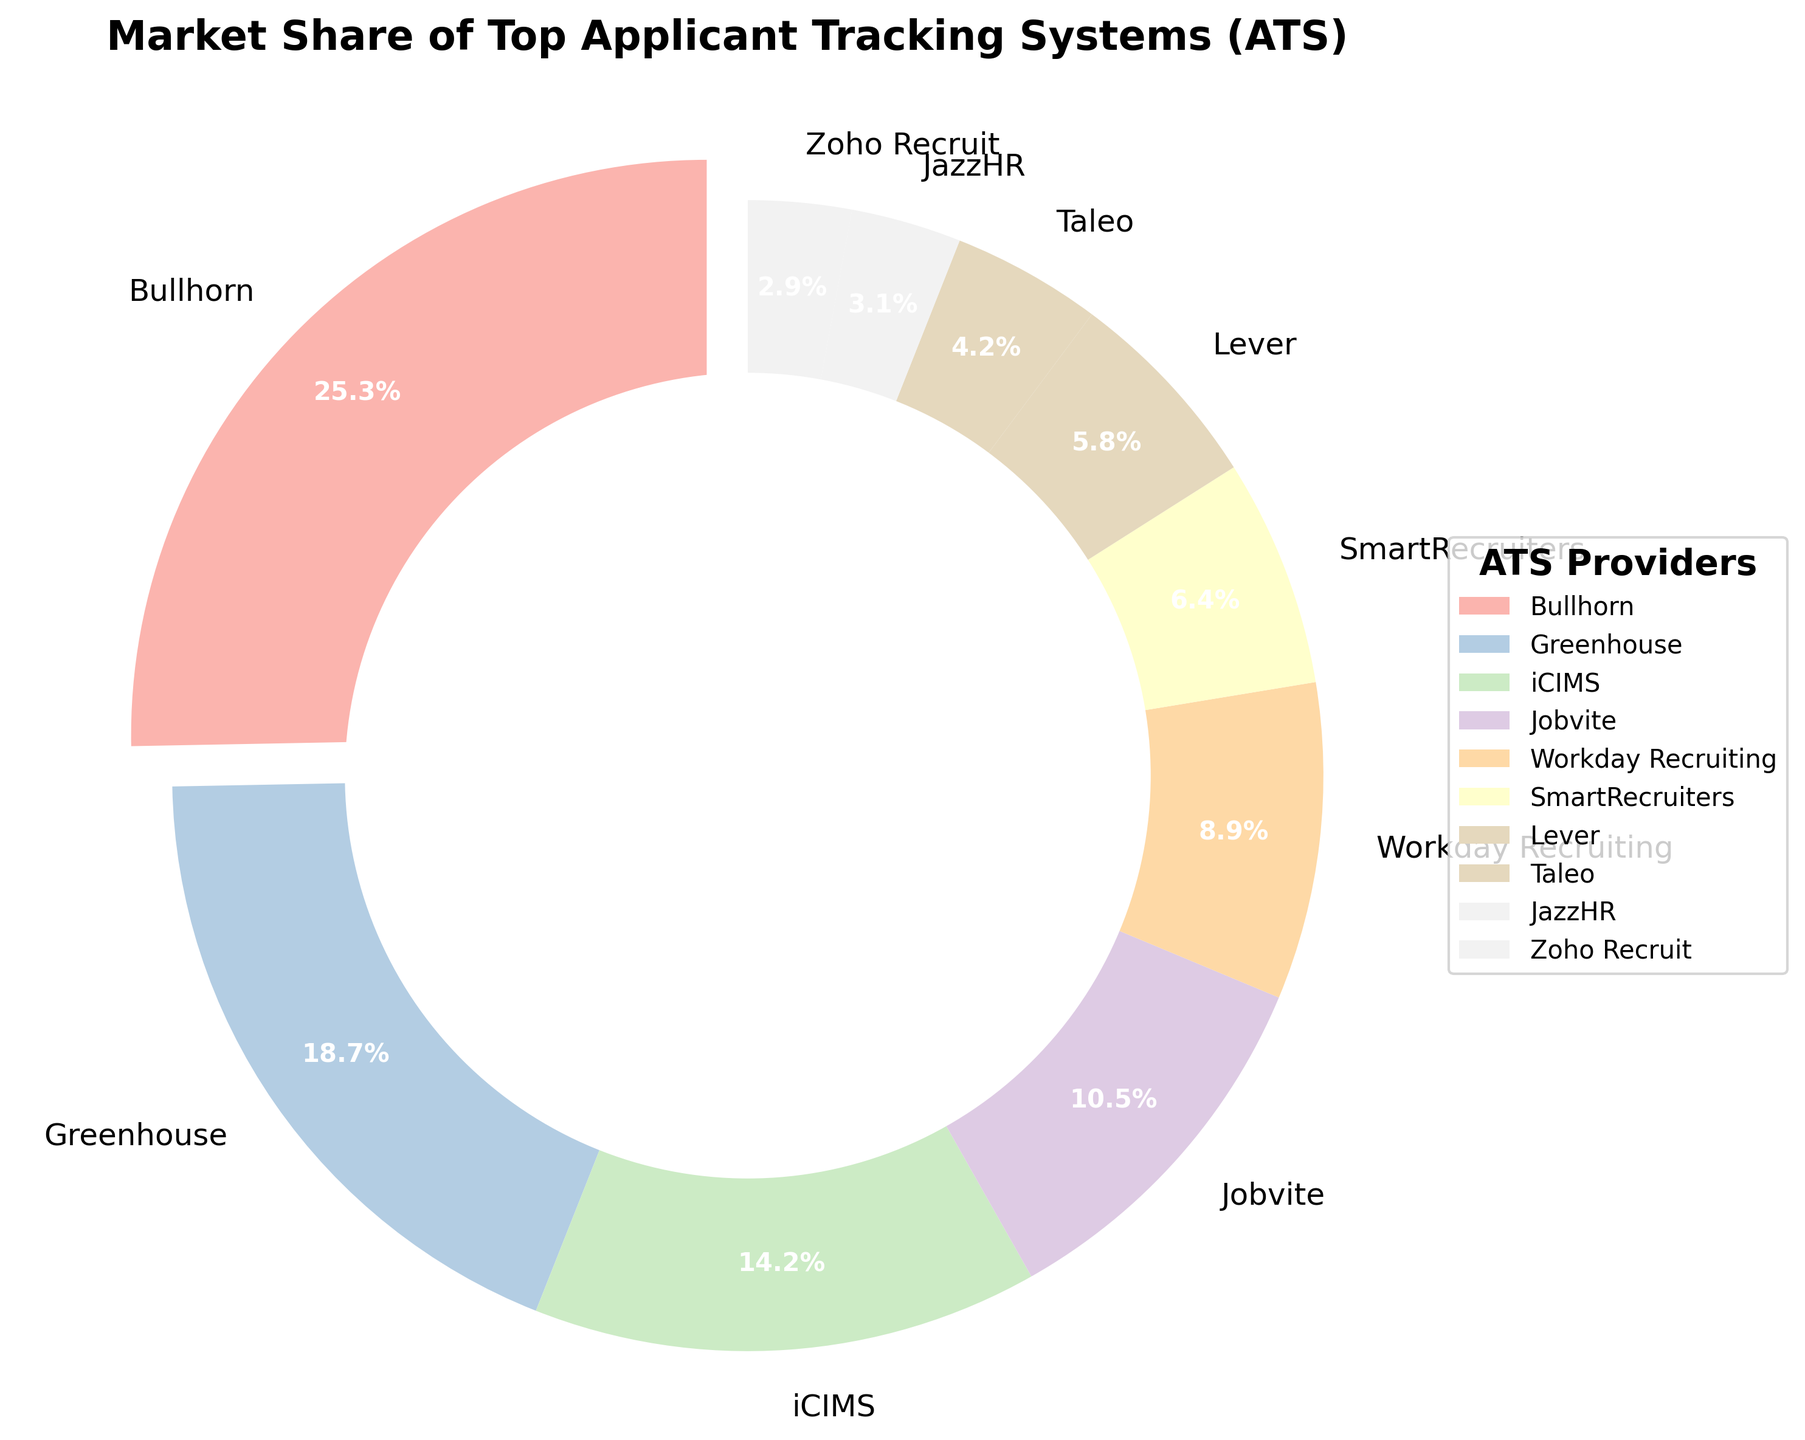Which ATS has the highest market share? The pie chart shows that Bullhorn has the largest segment with 25.3% of the market share.
Answer: Bullhorn Which ATS has the smallest market share? The pie chart shows that Zoho Recruit has the smallest segment with 2.9% of the market share.
Answer: Zoho Recruit How much larger is Bullhorn's market share compared to Greenhouse's? Bullhorn's market share is 25.3%, and Greenhouse's is 18.7%. Subtract Greenhouse’s share from Bullhorn’s share: 25.3% - 18.7% = 6.6%.
Answer: 6.6% What is the combined market share of the top three ATS providers? The top three ATS providers are Bullhorn (25.3%), Greenhouse (18.7%), and iCIMS (14.2%). Add their market shares: 25.3% + 18.7% + 14.2% = 58.2%.
Answer: 58.2% Which ATS has almost twice the market share of JazzHR? JazzHR has a market share of 3.1%. Lever has a market share of 5.8%, which is almost twice that of JazzHR (3.1% * 2 = 6.2%).
Answer: Lever Which segment has a color that stands out with a small discrepancy? The Bullhorn segment slightly explodes out from the center, making it visually stand out.
Answer: Bullhorn How much of the market share do the bottom five ATS providers capture collectively? The bottom five ATS providers are JazzHR (3.1%), Zoho Recruit (2.9%), Taleo (4.2%), Lever (5.8%), and SmartRecruiters (6.4%). Add their market shares: 3.1% + 2.9% + 4.2% + 5.8% + 6.4% = 22.4%.
Answer: 22.4% Which ATS has a market share that is less than half of Jobvite's share? Jobvite has a market share of 10.5%. Zoho Recruit has a market share of 2.9%, and since 2.9% < 10.5% / 2 = 5.25%, Zoho Recruit's share is less than half.
Answer: Zoho Recruit How does Workday Recruiting's market share compare to that of SmartRecruiters? Workday Recruiting has a market share of 8.9%, which is larger than SmartRecruiters' 6.4%.
Answer: Workday Recruiting What is the visual importance of the center circle in the pie chart? The white center circle creates a donut-like effect that improves readability by providing a clear separation between the pie slices and the chart's center.
Answer: Improves readability 